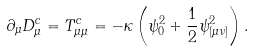Convert formula to latex. <formula><loc_0><loc_0><loc_500><loc_500>\partial _ { \mu } D _ { \mu } ^ { c } = T _ { \mu \mu } ^ { c } = - \kappa \left ( \psi _ { 0 } ^ { 2 } + \frac { 1 } { 2 } \psi _ { [ \mu \nu ] } ^ { 2 } \right ) .</formula> 